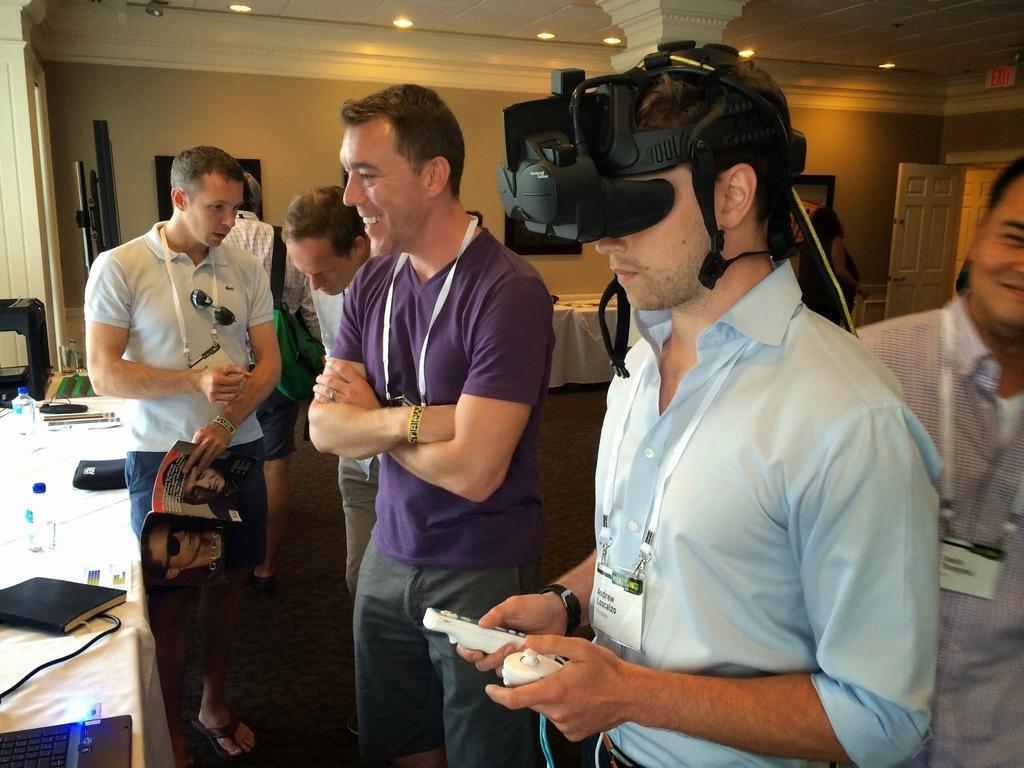Could you give a brief overview of what you see in this image? At the top we can see ceiling and lights. This is a wall. We can see persons standing on the floor near to the table. This man is holding a magazine in his hands. On the table we can see device, bottles, laptop with pen drive. This man is holding remotes in his hands and there is a gadget placed over his eyes. This is a door. 